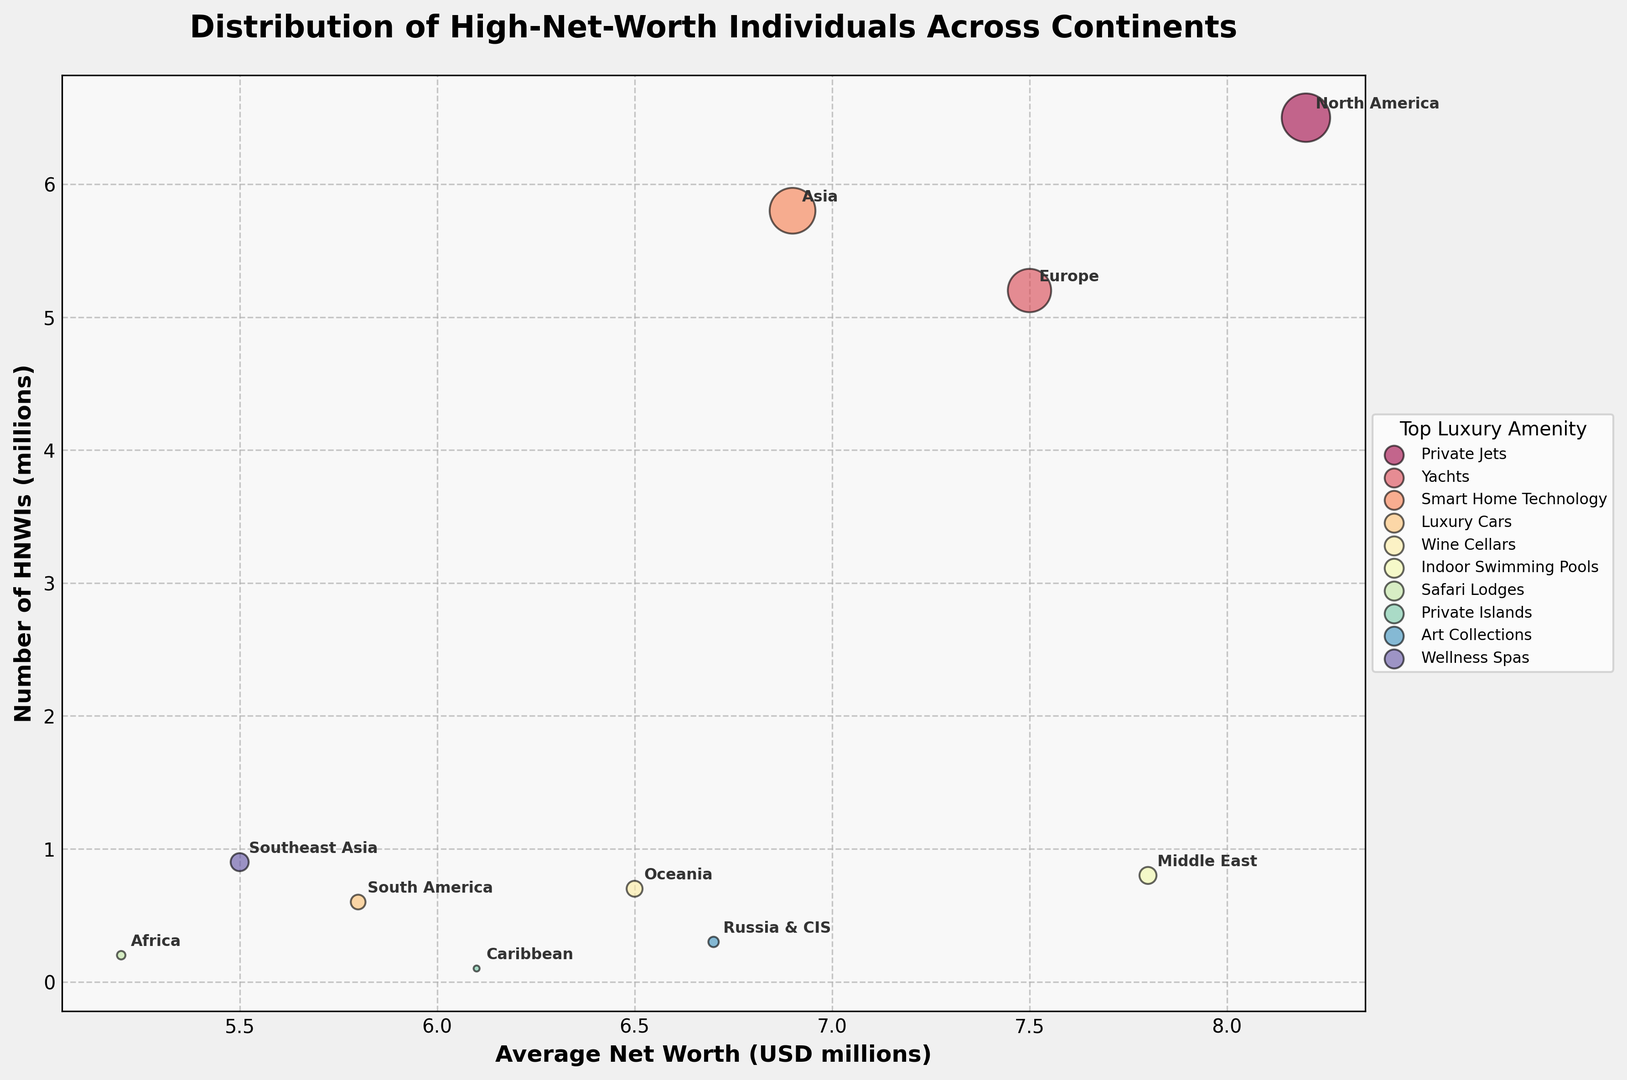Which continent has the highest number of HNWIs? The y-axis represents the number of HNWIs in millions. The bubble corresponding to North America is placed the highest on the y-axis.
Answer: North America Which continent has the lowest number of HNWIs? The bubble for the Caribbean is the smallest in size and lowest on the y-axis, indicating it has the lowest number of HNWIs.
Answer: Caribbean How does the average net worth of HNWIs in Europe compare to that in Asia? Europe and Asia have average net worths indicated on the x-axis, with Europe positioned at 7.5 million USD and Asia at 6.9 million USD. Europe is higher.
Answer: Europe is higher Which continent favors Private Jets as their top luxury amenity and how many HNWIs does it have? The legend lists Private Jets as an amenity, and the corresponding bubble (North America) can be identified on the graph. The y-axis shows it has 6.5 million HNWIs.
Answer: North America, 6.5 million What's the sum of HNWIs in Africa and Southeast Asia? The number of HNWIs in Africa is 0.2 million and in Southeast Asia is 0.9 million. Adding these gives 0.2 + 0.9 = 1.1 million.
Answer: 1.1 million Which continent has the highest average net worth and what is its corresponding top luxury amenity? The highest bubble on the x-axis represents North America with 8.2 million USD, and the legend shows its top luxury amenity as Private Jets.
Answer: North America, Private Jets Compare the bubble sizes for Middle East and Oceania. Which one is larger and what does this indicate? The Middle East bubble is larger than Oceania's bubble, indicating that the Middle East has more HNWIs. Specifically, Middle East has 0.8 million and Oceania has 0.7 million.
Answer: Middle East, more HNWIs What is the difference in the average net worth between South America and Russia & CIS? South America's average net worth is 5.8 million USD and Russia & CIS is 6.7 million USD on the x-axis. The difference is 6.7 - 5.8 = 0.9 million USD.
Answer: 0.9 million USD Which continent has a top luxury amenity of Safari Lodges and what is the average net worth there? The legend indicates Safari Lodges are the top luxury amenity for Africa. The corresponding bubble shows Africa's average net worth is 5.2 million USD.
Answer: Africa, 5.2 million USD 